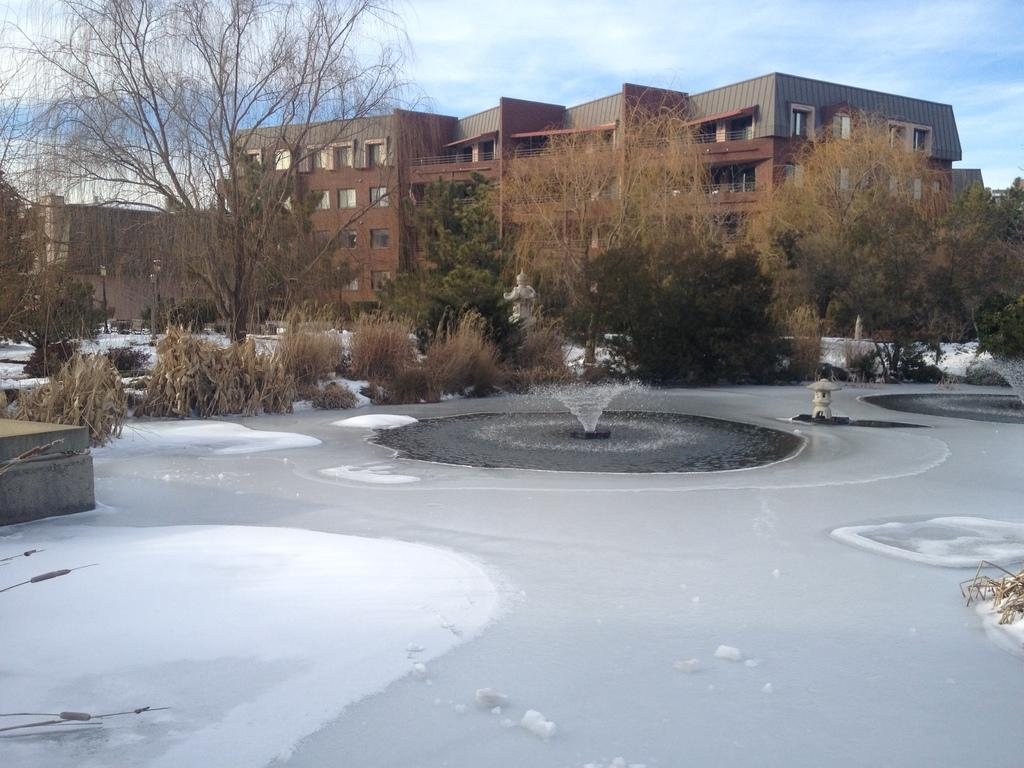What activity are the children engaged in, as described in the image? The children are playing on a playground. What specific playground equipment is mentioned in the image? There is a slide, a swing, and a seesaw. What type of guide is holding the crayon while drawing on the butter in the image? There is no guide, crayon, or butter present in the image. The image features a group of children playing on a playground with a slide, a swing, and a seesaw. 